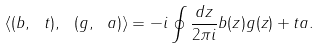<formula> <loc_0><loc_0><loc_500><loc_500>\langle ( b , \ t ) , \ ( g , \ a ) \rangle = - i \oint \frac { d z } { 2 \pi i } b ( z ) g ( z ) + t a .</formula> 